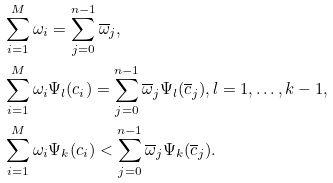Convert formula to latex. <formula><loc_0><loc_0><loc_500><loc_500>& \sum _ { i = 1 } ^ { M } \omega _ { i } = \sum _ { j = 0 } ^ { n - 1 } \overline { \omega } _ { j } , \\ & \sum _ { i = 1 } ^ { M } \omega _ { i } \Psi _ { l } ( c _ { i } ) = \sum _ { j = 0 } ^ { n - 1 } \overline { \omega } _ { j } \Psi _ { l } ( \overline { c } _ { j } ) , l = 1 , \dots , k - 1 , \\ & \sum _ { i = 1 } ^ { M } \omega _ { i } \Psi _ { k } ( c _ { i } ) < \sum _ { j = 0 } ^ { n - 1 } \overline { \omega } _ { j } \Psi _ { k } ( \overline { c } _ { j } ) .</formula> 